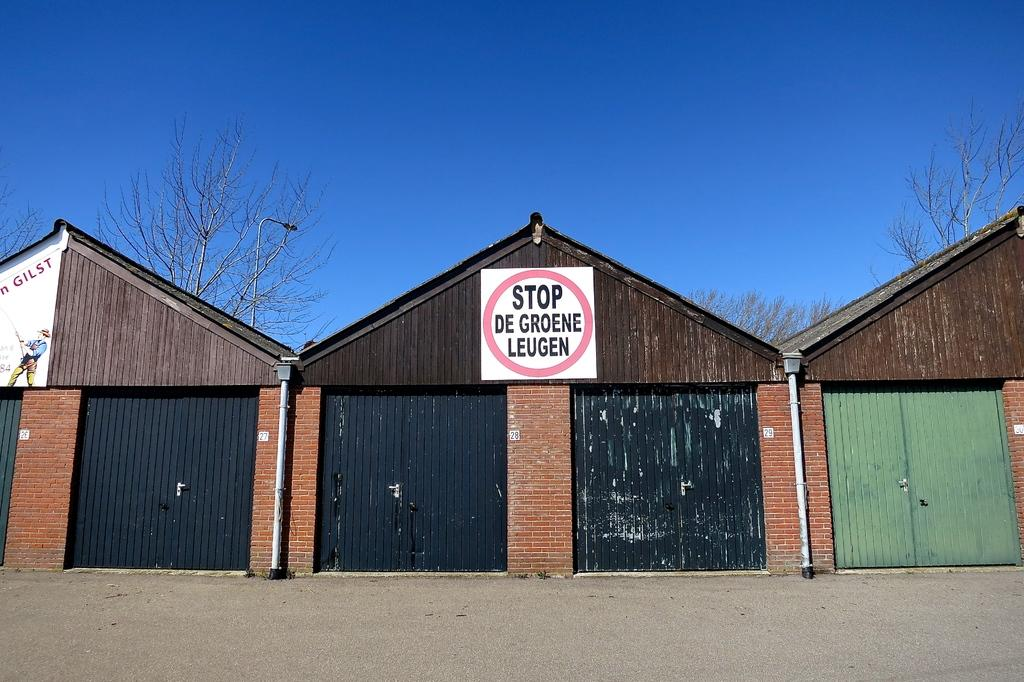What is located in the center of the image? There are trees, a street light, and buildings in the center of the image. What type of vegetation is present in the image? There are trees in the image. What type of structure is present in the image? There is a street light and buildings in the image. What is the terrain like in the foreground of the image? The foreground of the image consists of land. What can be seen in the background of the image? The sky is visible in the background of the image. How many frogs are sitting on the plate in the image? There are no frogs or plates present in the image. What type of selection is available in the image? There is no selection or menu present in the image. 